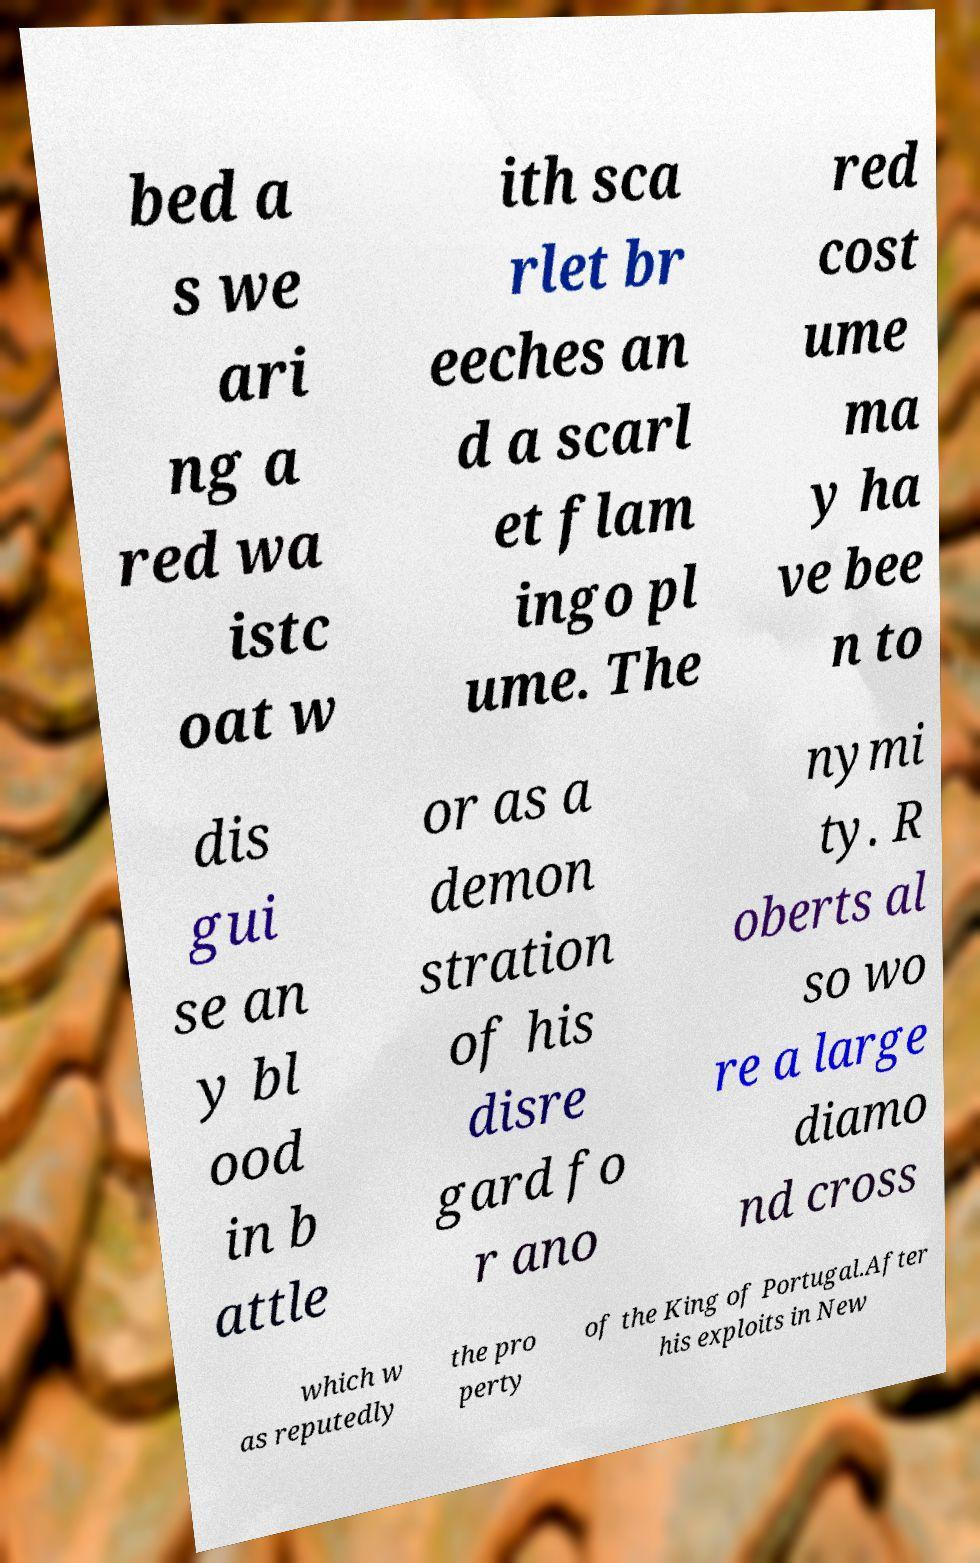Can you accurately transcribe the text from the provided image for me? bed a s we ari ng a red wa istc oat w ith sca rlet br eeches an d a scarl et flam ingo pl ume. The red cost ume ma y ha ve bee n to dis gui se an y bl ood in b attle or as a demon stration of his disre gard fo r ano nymi ty. R oberts al so wo re a large diamo nd cross which w as reputedly the pro perty of the King of Portugal.After his exploits in New 